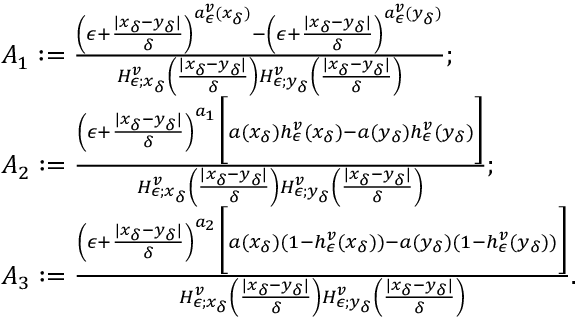<formula> <loc_0><loc_0><loc_500><loc_500>\begin{array} { r l } & { A _ { 1 } \colon = \frac { \left ( \epsilon + \frac { | x _ { \delta } - y _ { \delta } | } { \delta } \right ) ^ { a _ { \epsilon } ^ { v } ( x _ { \delta } ) } - \left ( \epsilon + \frac { | x _ { \delta } - y _ { \delta } | } { \delta } \right ) ^ { a _ { \epsilon } ^ { v } ( y _ { \delta } ) } } { H _ { \epsilon ; x _ { \delta } } ^ { v } \left ( \frac { | x _ { \delta } - y _ { \delta } | } { \delta } \right ) H _ { \epsilon ; y _ { \delta } } ^ { v } \left ( \frac { | x _ { \delta } - y _ { \delta } | } { \delta } \right ) } ; } \\ & { A _ { 2 } \colon = \frac { \left ( \epsilon + \frac { | x _ { \delta } - y _ { \delta } | } { \delta } \right ) ^ { a _ { 1 } } \left [ a ( x _ { \delta } ) h _ { \epsilon } ^ { v } ( x _ { \delta } ) - a ( y _ { \delta } ) h _ { \epsilon } ^ { v } ( y _ { \delta } ) \right ] } { H _ { \epsilon ; x _ { \delta } } ^ { v } \left ( \frac { | x _ { \delta } - y _ { \delta } | } { \delta } \right ) H _ { \epsilon ; y _ { \delta } } ^ { v } \left ( \frac { | x _ { \delta } - y _ { \delta } | } { \delta } \right ) } ; } \\ & { A _ { 3 } \colon = \frac { \left ( \epsilon + \frac { | x _ { \delta } - y _ { \delta } | } { \delta } \right ) ^ { a _ { 2 } } \left [ a ( x _ { \delta } ) ( 1 - h _ { \epsilon } ^ { v } ( x _ { \delta } ) ) - a ( y _ { \delta } ) ( 1 - h _ { \epsilon } ^ { v } ( y _ { \delta } ) ) \right ] } { H _ { \epsilon ; x _ { \delta } } ^ { v } \left ( \frac { | x _ { \delta } - y _ { \delta } | } { \delta } \right ) H _ { \epsilon ; y _ { \delta } } ^ { v } \left ( \frac { | x _ { \delta } - y _ { \delta } | } { \delta } \right ) } . } \end{array}</formula> 